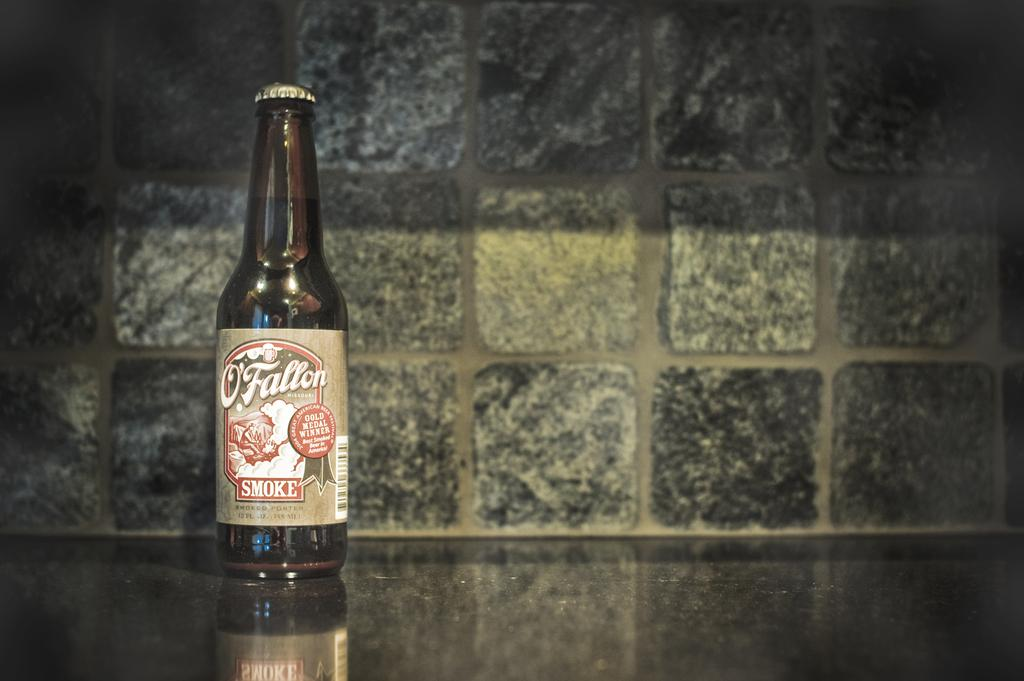Provide a one-sentence caption for the provided image. The bottle of O'Fallon was a Gold Medal Winner. 